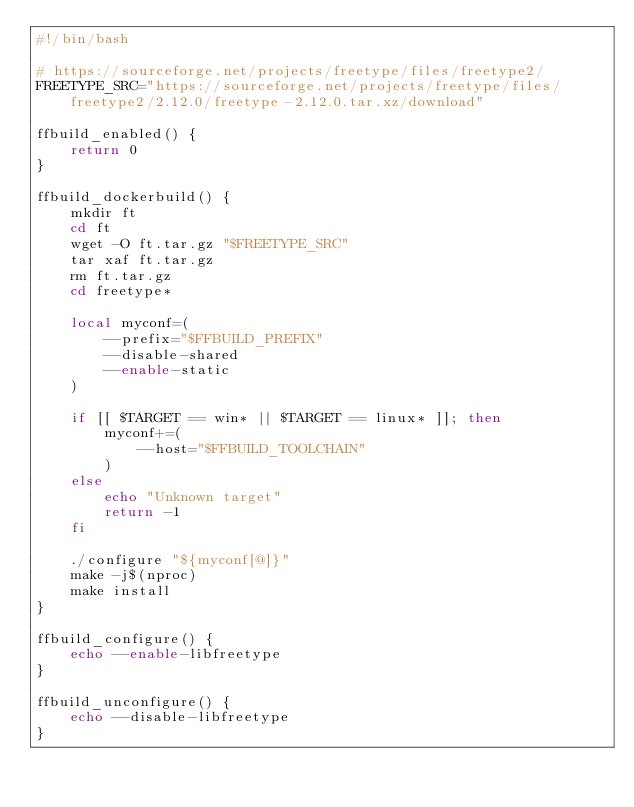Convert code to text. <code><loc_0><loc_0><loc_500><loc_500><_Bash_>#!/bin/bash

# https://sourceforge.net/projects/freetype/files/freetype2/
FREETYPE_SRC="https://sourceforge.net/projects/freetype/files/freetype2/2.12.0/freetype-2.12.0.tar.xz/download"

ffbuild_enabled() {
    return 0
}

ffbuild_dockerbuild() {
    mkdir ft
    cd ft
    wget -O ft.tar.gz "$FREETYPE_SRC"
    tar xaf ft.tar.gz
    rm ft.tar.gz
    cd freetype*

    local myconf=(
        --prefix="$FFBUILD_PREFIX"
        --disable-shared
        --enable-static
    )

    if [[ $TARGET == win* || $TARGET == linux* ]]; then
        myconf+=(
            --host="$FFBUILD_TOOLCHAIN"
        )
    else
        echo "Unknown target"
        return -1
    fi

    ./configure "${myconf[@]}"
    make -j$(nproc)
    make install
}

ffbuild_configure() {
    echo --enable-libfreetype
}

ffbuild_unconfigure() {
    echo --disable-libfreetype
}
</code> 